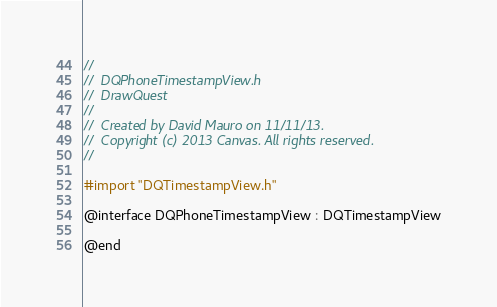<code> <loc_0><loc_0><loc_500><loc_500><_C_>//
//  DQPhoneTimestampView.h
//  DrawQuest
//
//  Created by David Mauro on 11/11/13.
//  Copyright (c) 2013 Canvas. All rights reserved.
//

#import "DQTimestampView.h"

@interface DQPhoneTimestampView : DQTimestampView

@end
</code> 